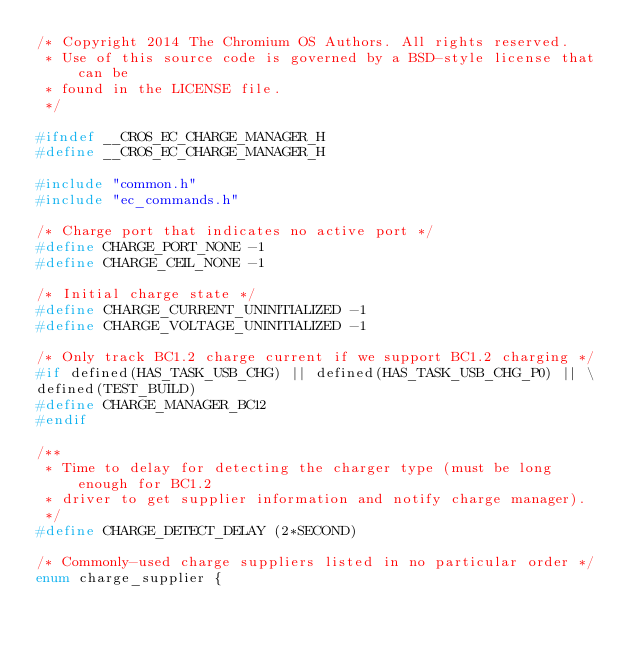<code> <loc_0><loc_0><loc_500><loc_500><_C_>/* Copyright 2014 The Chromium OS Authors. All rights reserved.
 * Use of this source code is governed by a BSD-style license that can be
 * found in the LICENSE file.
 */

#ifndef __CROS_EC_CHARGE_MANAGER_H
#define __CROS_EC_CHARGE_MANAGER_H

#include "common.h"
#include "ec_commands.h"

/* Charge port that indicates no active port */
#define CHARGE_PORT_NONE -1
#define CHARGE_CEIL_NONE -1

/* Initial charge state */
#define CHARGE_CURRENT_UNINITIALIZED -1
#define CHARGE_VOLTAGE_UNINITIALIZED -1

/* Only track BC1.2 charge current if we support BC1.2 charging */
#if defined(HAS_TASK_USB_CHG) || defined(HAS_TASK_USB_CHG_P0) || \
defined(TEST_BUILD)
#define CHARGE_MANAGER_BC12
#endif

/**
 * Time to delay for detecting the charger type (must be long enough for BC1.2
 * driver to get supplier information and notify charge manager).
 */
#define CHARGE_DETECT_DELAY (2*SECOND)

/* Commonly-used charge suppliers listed in no particular order */
enum charge_supplier {</code> 